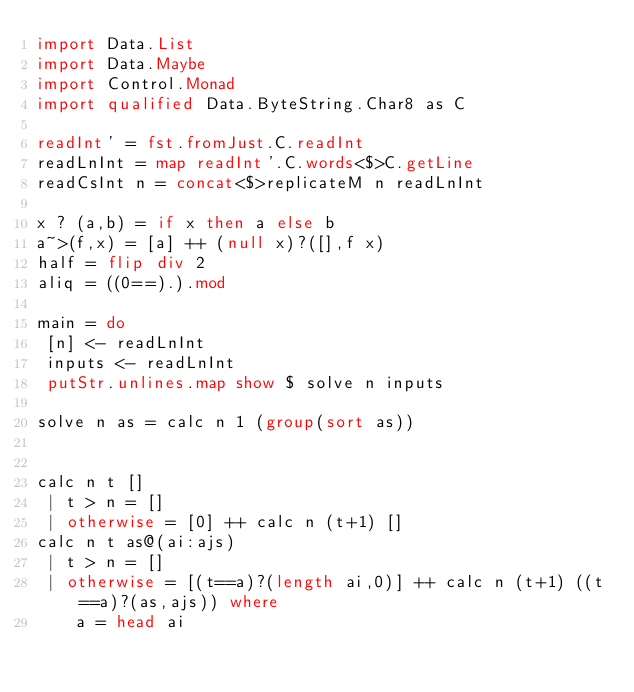<code> <loc_0><loc_0><loc_500><loc_500><_Haskell_>import Data.List
import Data.Maybe
import Control.Monad
import qualified Data.ByteString.Char8 as C

readInt' = fst.fromJust.C.readInt
readLnInt = map readInt'.C.words<$>C.getLine
readCsInt n = concat<$>replicateM n readLnInt

x ? (a,b) = if x then a else b
a~>(f,x) = [a] ++ (null x)?([],f x)
half = flip div 2
aliq = ((0==).).mod

main = do
 [n] <- readLnInt
 inputs <- readLnInt
 putStr.unlines.map show $ solve n inputs

solve n as = calc n 1 (group(sort as))


calc n t []
 | t > n = []
 | otherwise = [0] ++ calc n (t+1) []
calc n t as@(ai:ajs)
 | t > n = []
 | otherwise = [(t==a)?(length ai,0)] ++ calc n (t+1) ((t==a)?(as,ajs)) where
    a = head ai
</code> 